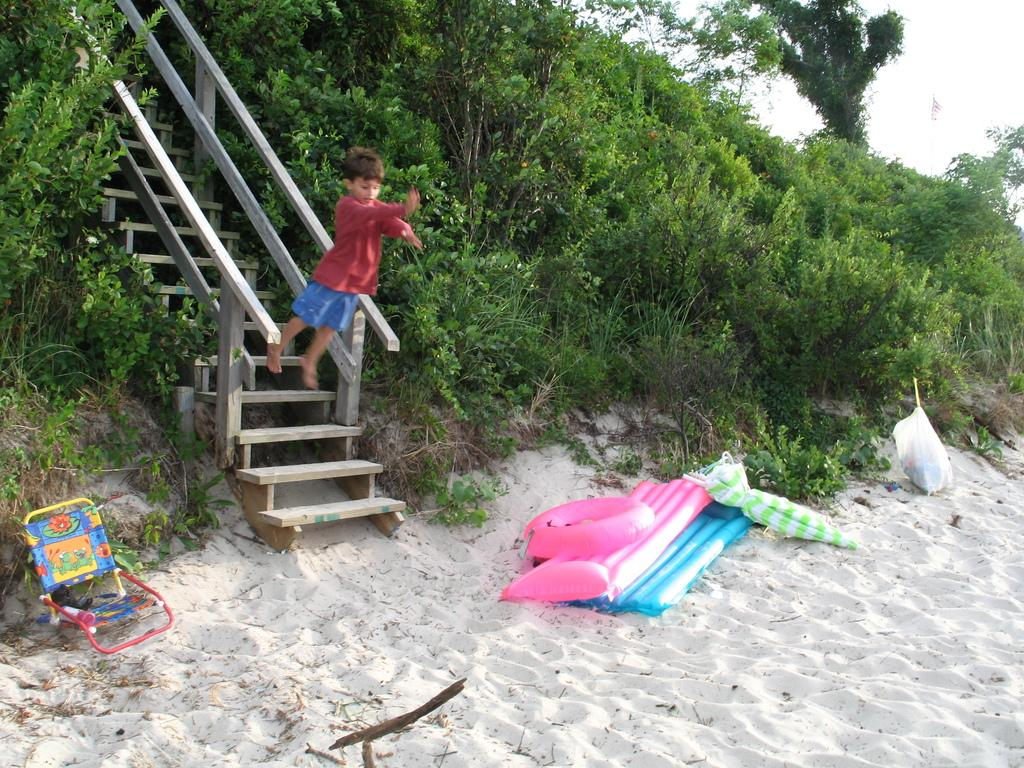What type of object is present in the image to provide shade or protection from the elements? There is an umbrella in the image. What is covering the objects in the image? There is a cover in the image. What type of seating is available in the image? There are inflatable chairs and a chair in the image. What other inflatable object is present in the image? There is an inflatable ring in the image. Where are the objects located in the image? The objects are on the sand. What architectural feature is present in the image? There is a staircase in the image. What type of vegetation is visible in the image? There are plants, grass, and trees in the image. What is visible in the sky in the image? The sky is visible in the image. What activity is the boy performing in the image? The boy is jumping from the staircase in the image. Where is the nearest shop to purchase a zephyr in the image? There is no mention of a shop or a zephyr in the image. What type of space vehicle can be seen in the image? There is no space vehicle present in the image. 